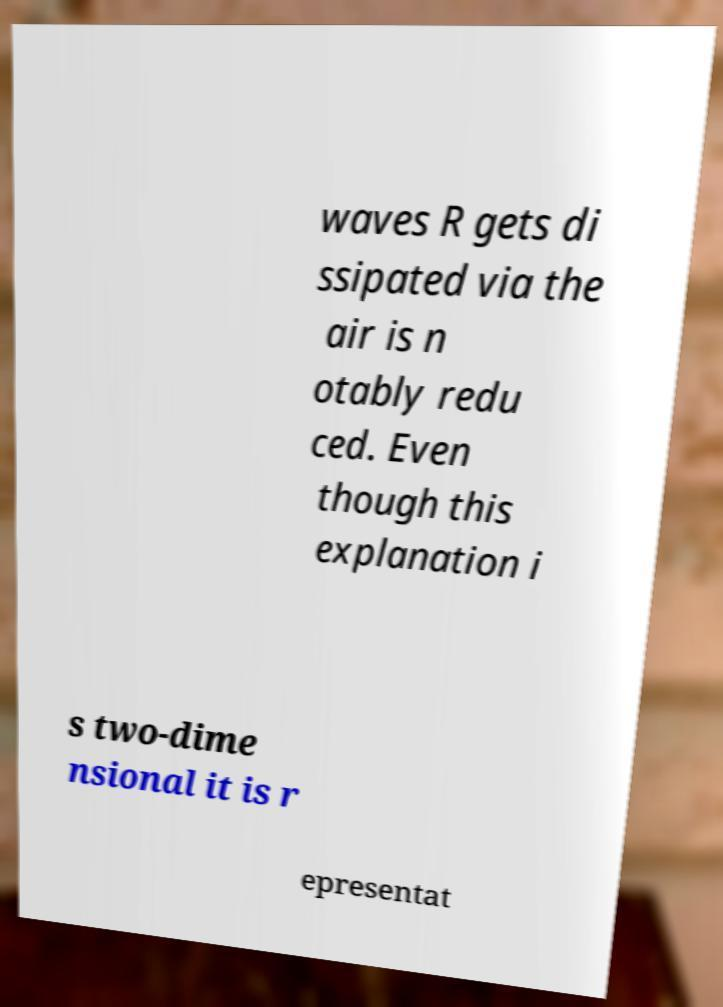Could you assist in decoding the text presented in this image and type it out clearly? waves R gets di ssipated via the air is n otably redu ced. Even though this explanation i s two-dime nsional it is r epresentat 